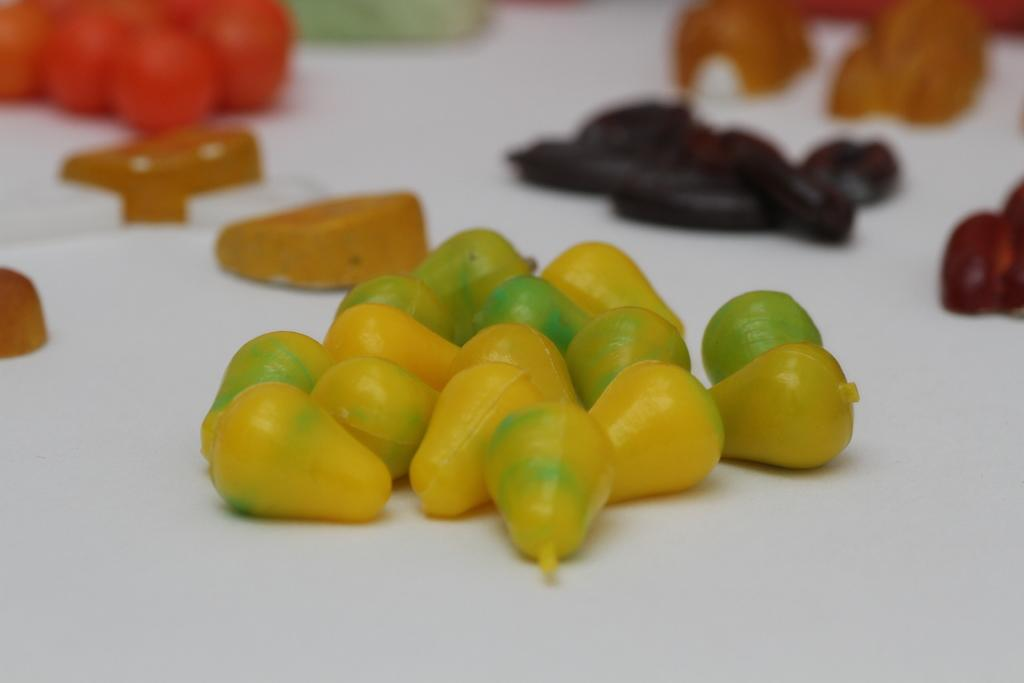What can be seen in the image? There are food items in the image. What is the color of the surface on which the food items are placed? The food items are on a white surface. What type of leather material is visible in the image? There is no leather material present in the image. 